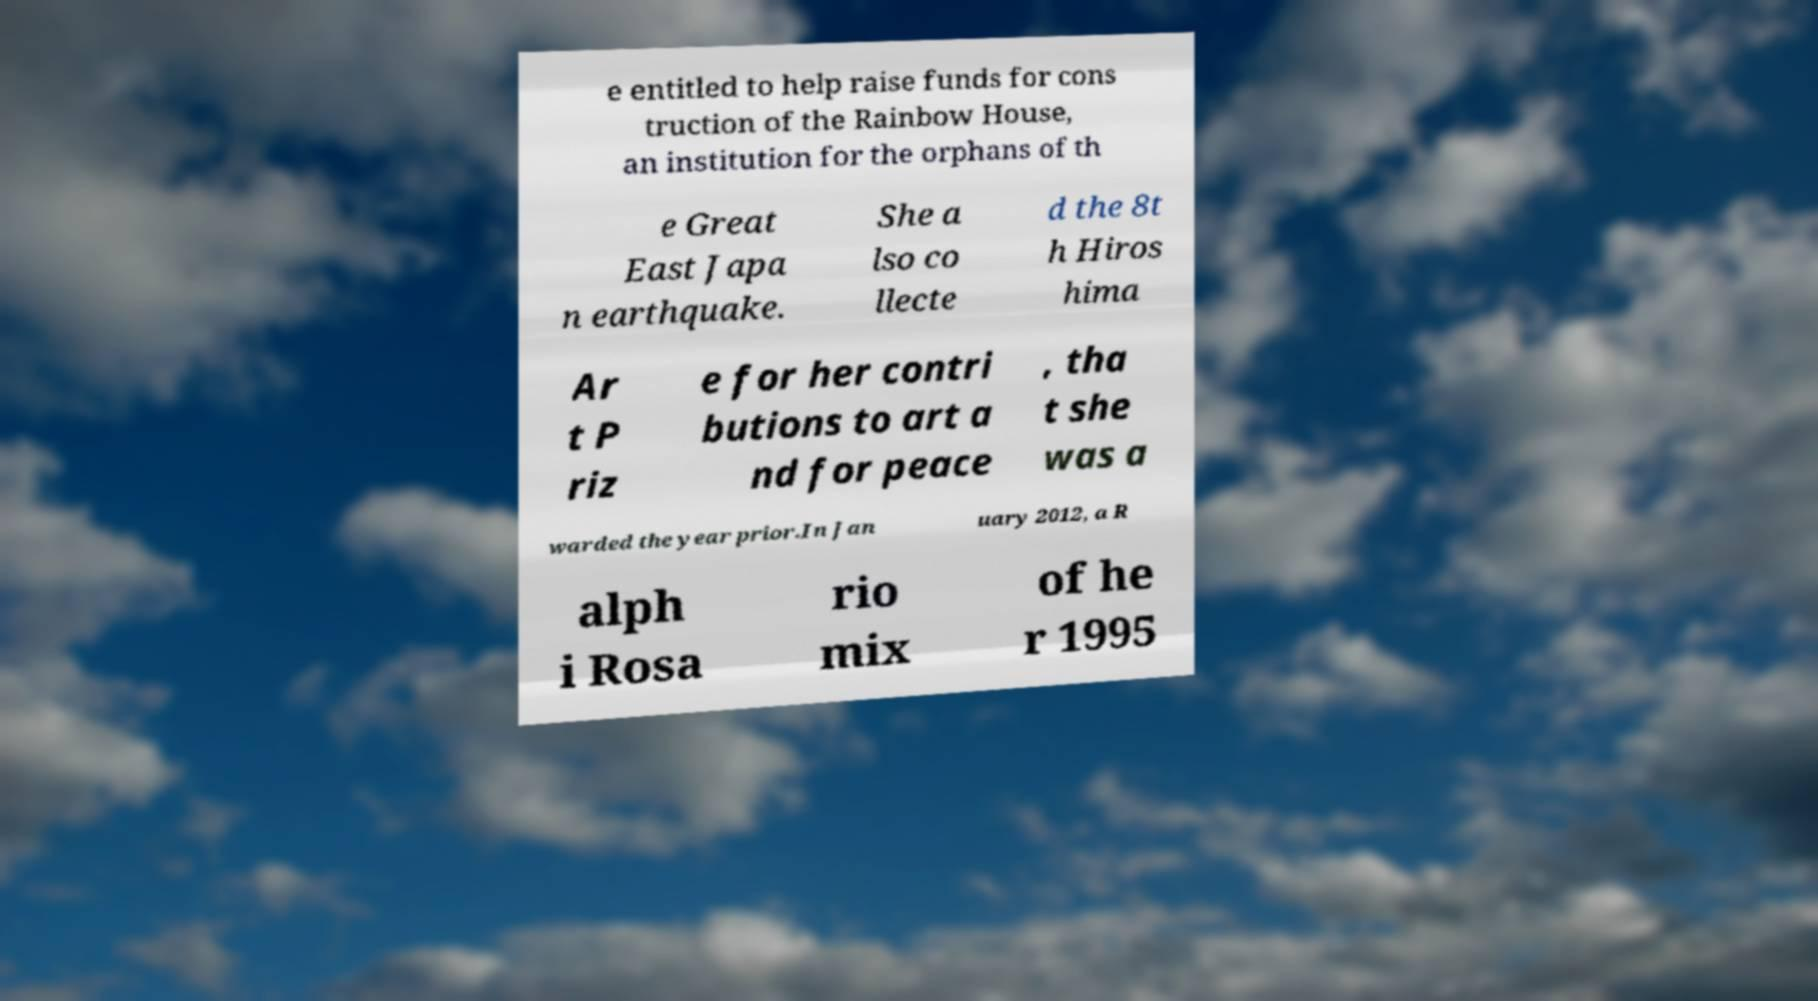What messages or text are displayed in this image? I need them in a readable, typed format. e entitled to help raise funds for cons truction of the Rainbow House, an institution for the orphans of th e Great East Japa n earthquake. She a lso co llecte d the 8t h Hiros hima Ar t P riz e for her contri butions to art a nd for peace , tha t she was a warded the year prior.In Jan uary 2012, a R alph i Rosa rio mix of he r 1995 